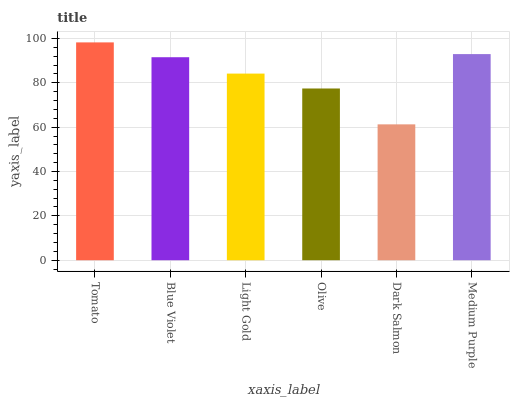Is Dark Salmon the minimum?
Answer yes or no. Yes. Is Tomato the maximum?
Answer yes or no. Yes. Is Blue Violet the minimum?
Answer yes or no. No. Is Blue Violet the maximum?
Answer yes or no. No. Is Tomato greater than Blue Violet?
Answer yes or no. Yes. Is Blue Violet less than Tomato?
Answer yes or no. Yes. Is Blue Violet greater than Tomato?
Answer yes or no. No. Is Tomato less than Blue Violet?
Answer yes or no. No. Is Blue Violet the high median?
Answer yes or no. Yes. Is Light Gold the low median?
Answer yes or no. Yes. Is Tomato the high median?
Answer yes or no. No. Is Olive the low median?
Answer yes or no. No. 